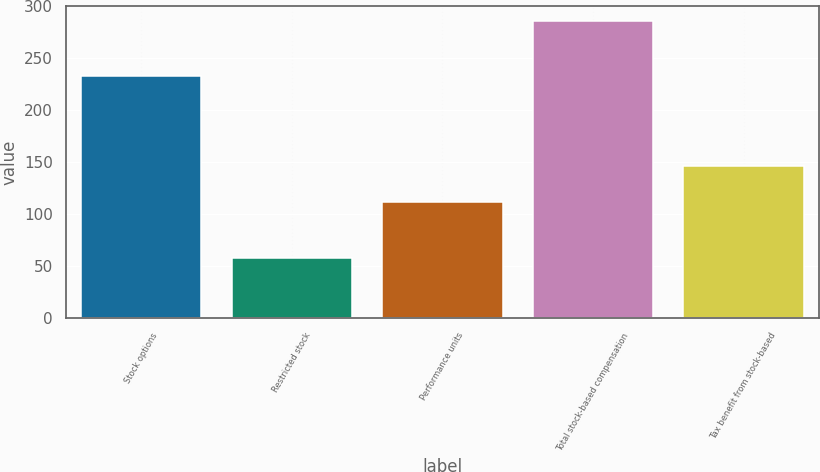Convert chart. <chart><loc_0><loc_0><loc_500><loc_500><bar_chart><fcel>Stock options<fcel>Restricted stock<fcel>Performance units<fcel>Total stock-based compensation<fcel>Tax benefit from stock-based<nl><fcel>233<fcel>58<fcel>112<fcel>286<fcel>146.5<nl></chart> 